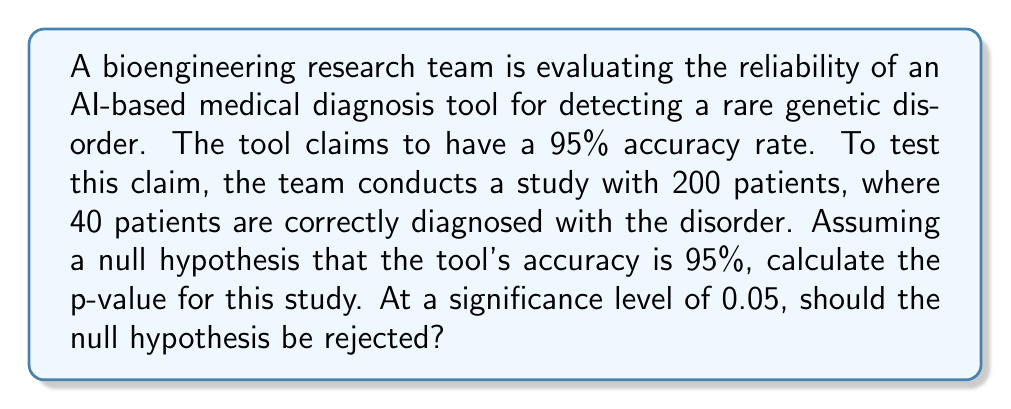Can you answer this question? Let's approach this step-by-step:

1) First, we need to identify the appropriate hypothesis test. Since we're dealing with a proportion (accuracy rate), we'll use a one-sample z-test for proportions.

2) Set up the hypotheses:
   $H_0: p = 0.95$ (null hypothesis)
   $H_a: p \neq 0.95$ (two-tailed alternative hypothesis)

3) Calculate the sample proportion:
   $\hat{p} = \frac{40}{200} = 0.20$

4) Calculate the standard error:
   $SE = \sqrt{\frac{p_0(1-p_0)}{n}} = \sqrt{\frac{0.95(1-0.95)}{200}} = 0.0154$

5) Calculate the z-score:
   $z = \frac{\hat{p} - p_0}{SE} = \frac{0.20 - 0.95}{0.0154} = -48.70$

6) Find the p-value:
   For a two-tailed test, p-value = $2 \times P(Z < -48.70)$
   This is an extremely small value, effectively 0.

7) Decision rule:
   Reject $H_0$ if p-value < significance level (0.05)

8) Since p-value (≈ 0) < 0.05, we reject the null hypothesis.
Answer: p-value ≈ 0; Reject $H_0$ 